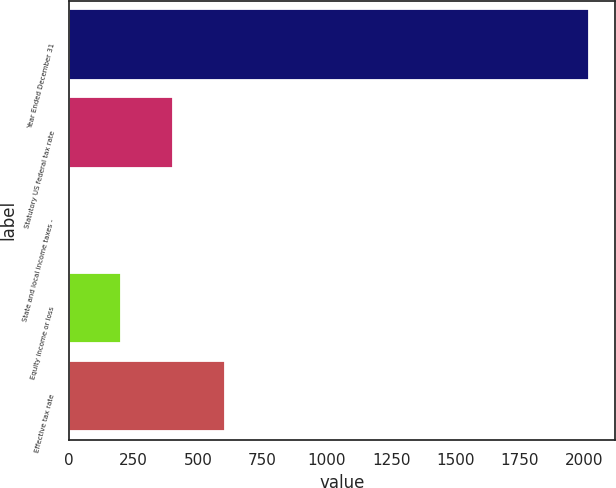Convert chart to OTSL. <chart><loc_0><loc_0><loc_500><loc_500><bar_chart><fcel>Year Ended December 31<fcel>Statutory US federal tax rate<fcel>State and local income taxes -<fcel>Equity income or loss<fcel>Effective tax rate<nl><fcel>2017<fcel>404.36<fcel>1.2<fcel>202.78<fcel>605.94<nl></chart> 